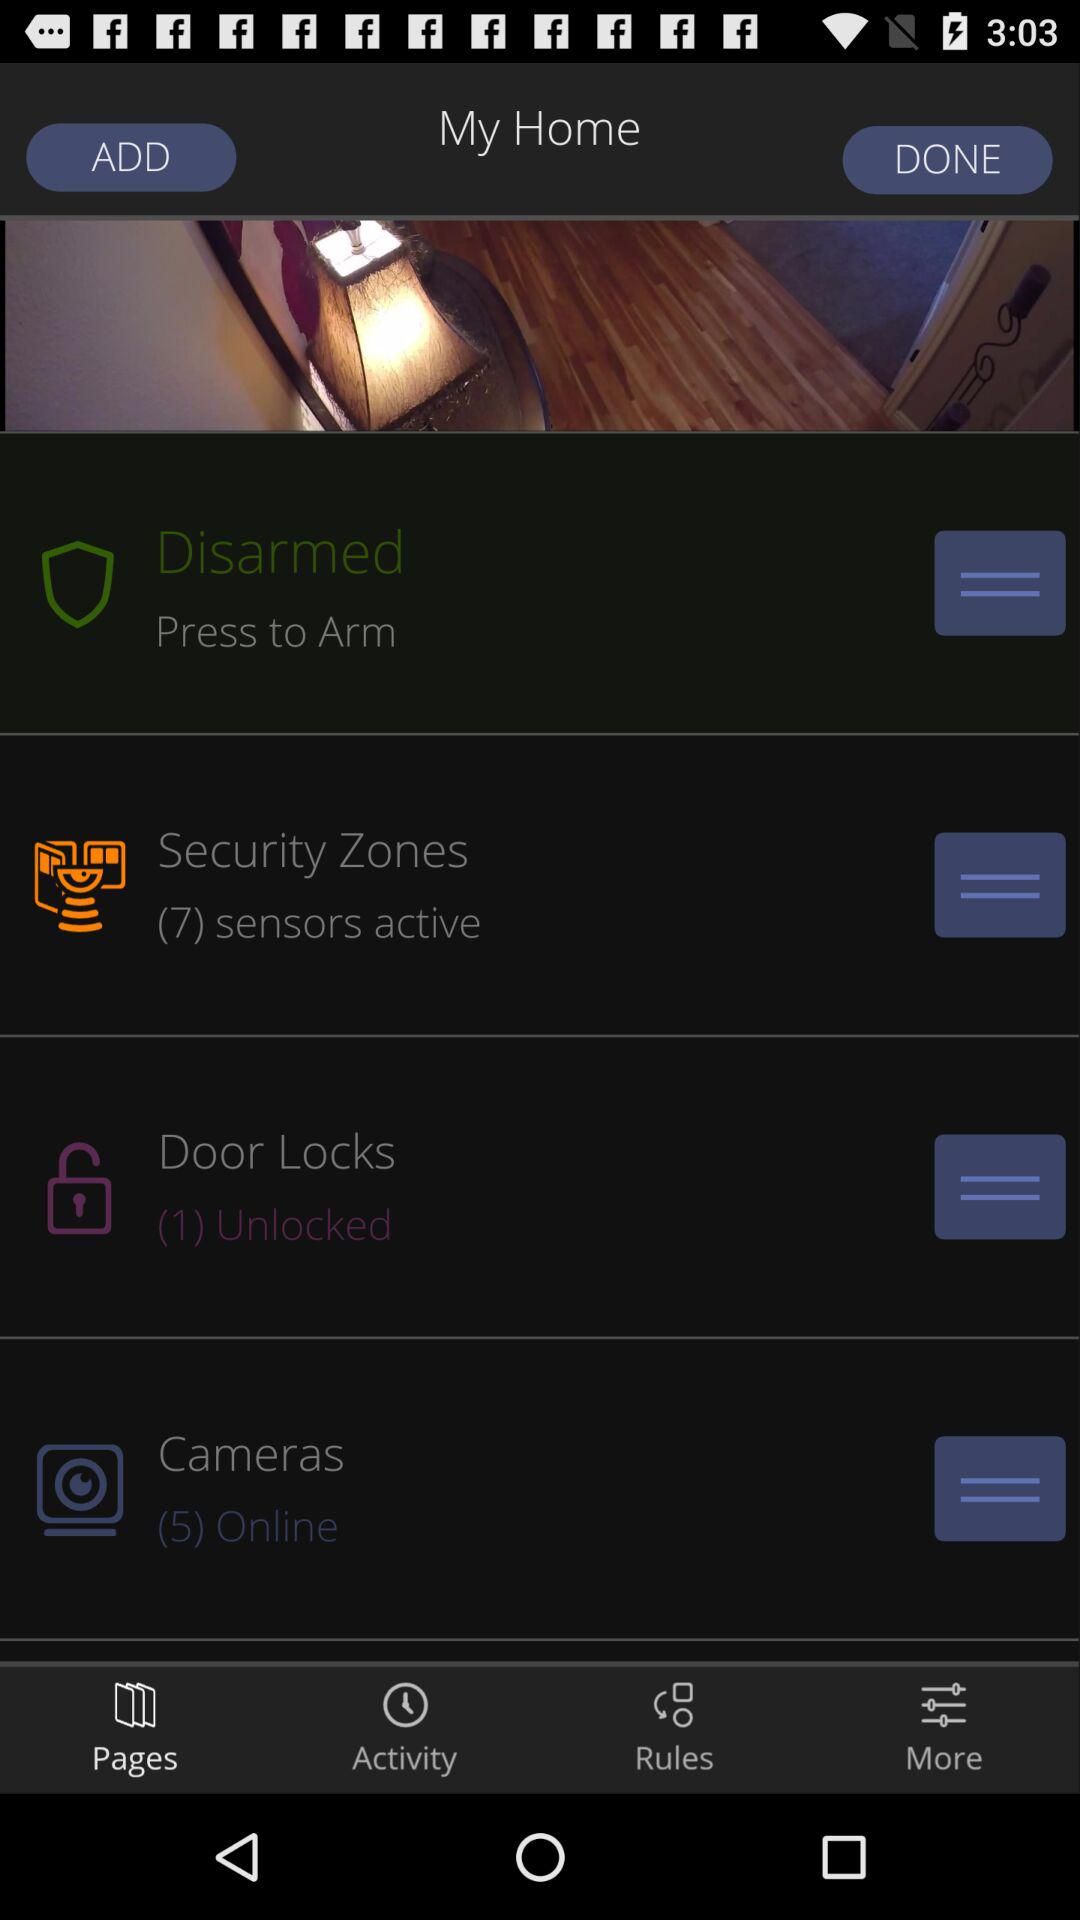How many sensors are active?
Answer the question using a single word or phrase. 7 